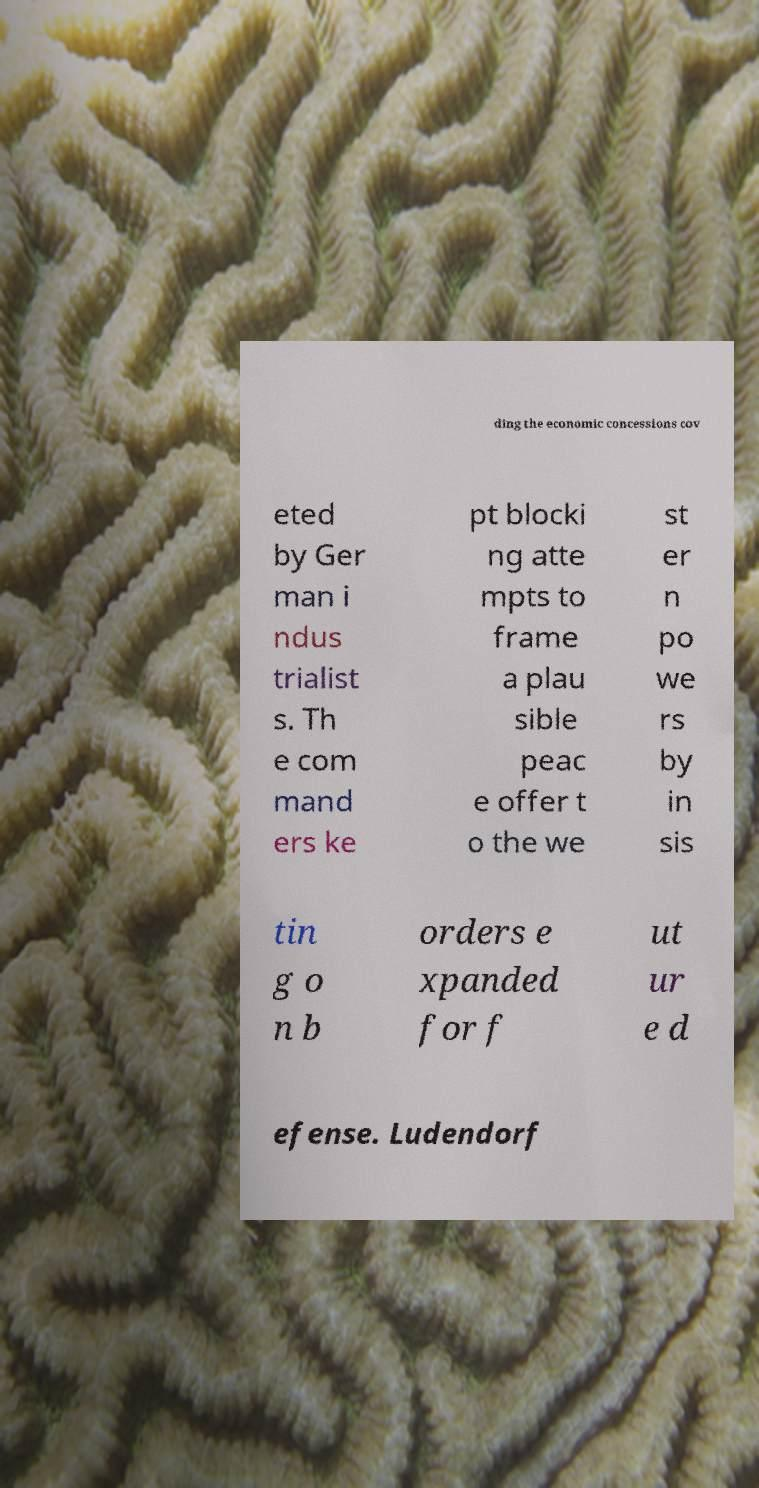There's text embedded in this image that I need extracted. Can you transcribe it verbatim? ding the economic concessions cov eted by Ger man i ndus trialist s. Th e com mand ers ke pt blocki ng atte mpts to frame a plau sible peac e offer t o the we st er n po we rs by in sis tin g o n b orders e xpanded for f ut ur e d efense. Ludendorf 